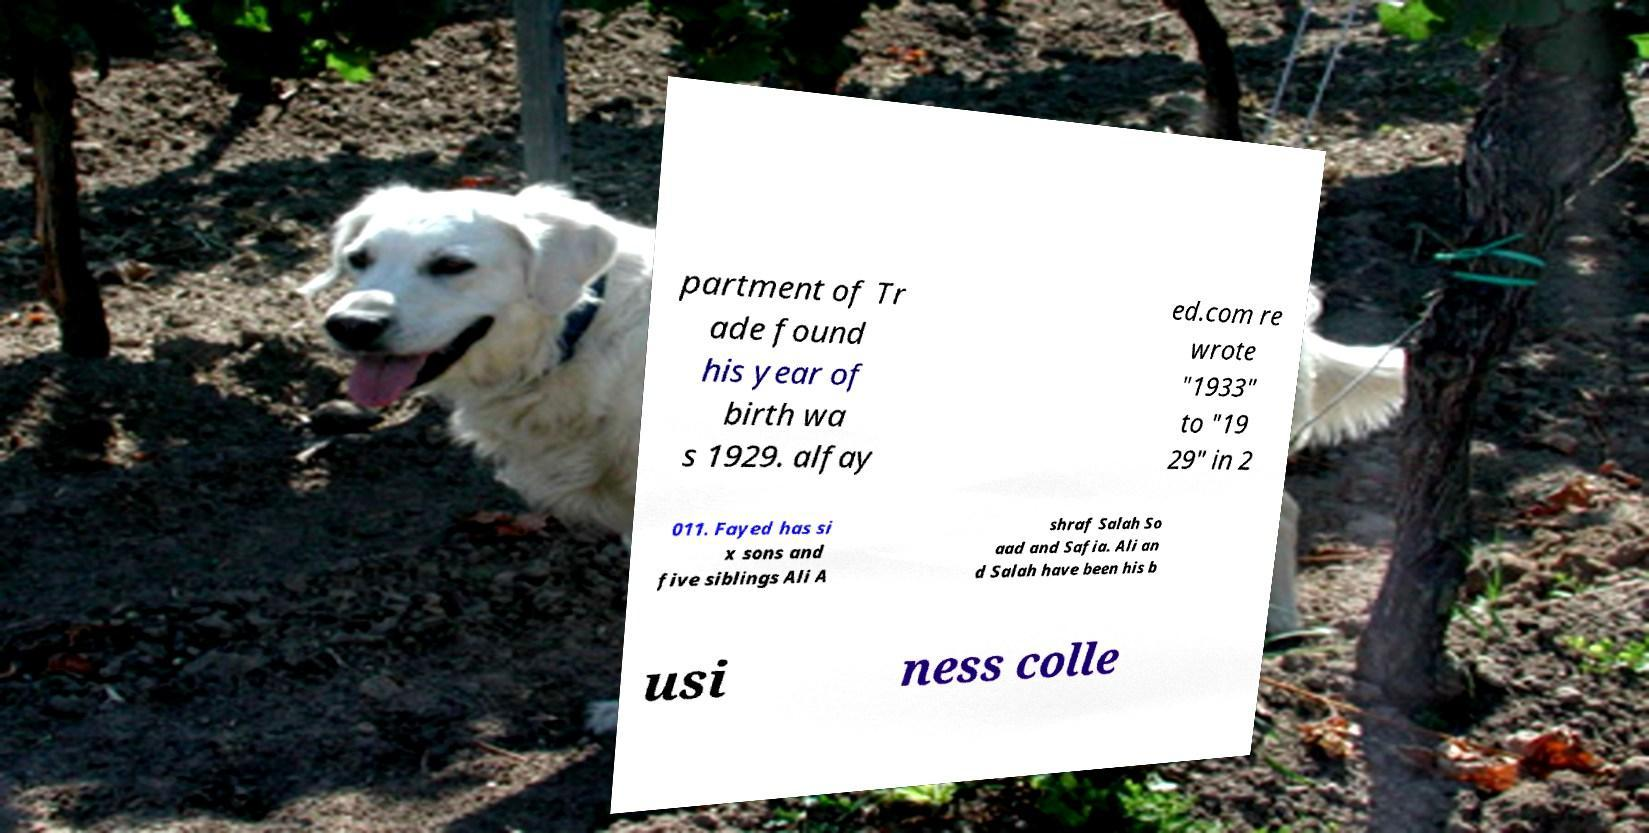What messages or text are displayed in this image? I need them in a readable, typed format. partment of Tr ade found his year of birth wa s 1929. alfay ed.com re wrote "1933" to "19 29" in 2 011. Fayed has si x sons and five siblings Ali A shraf Salah So aad and Safia. Ali an d Salah have been his b usi ness colle 